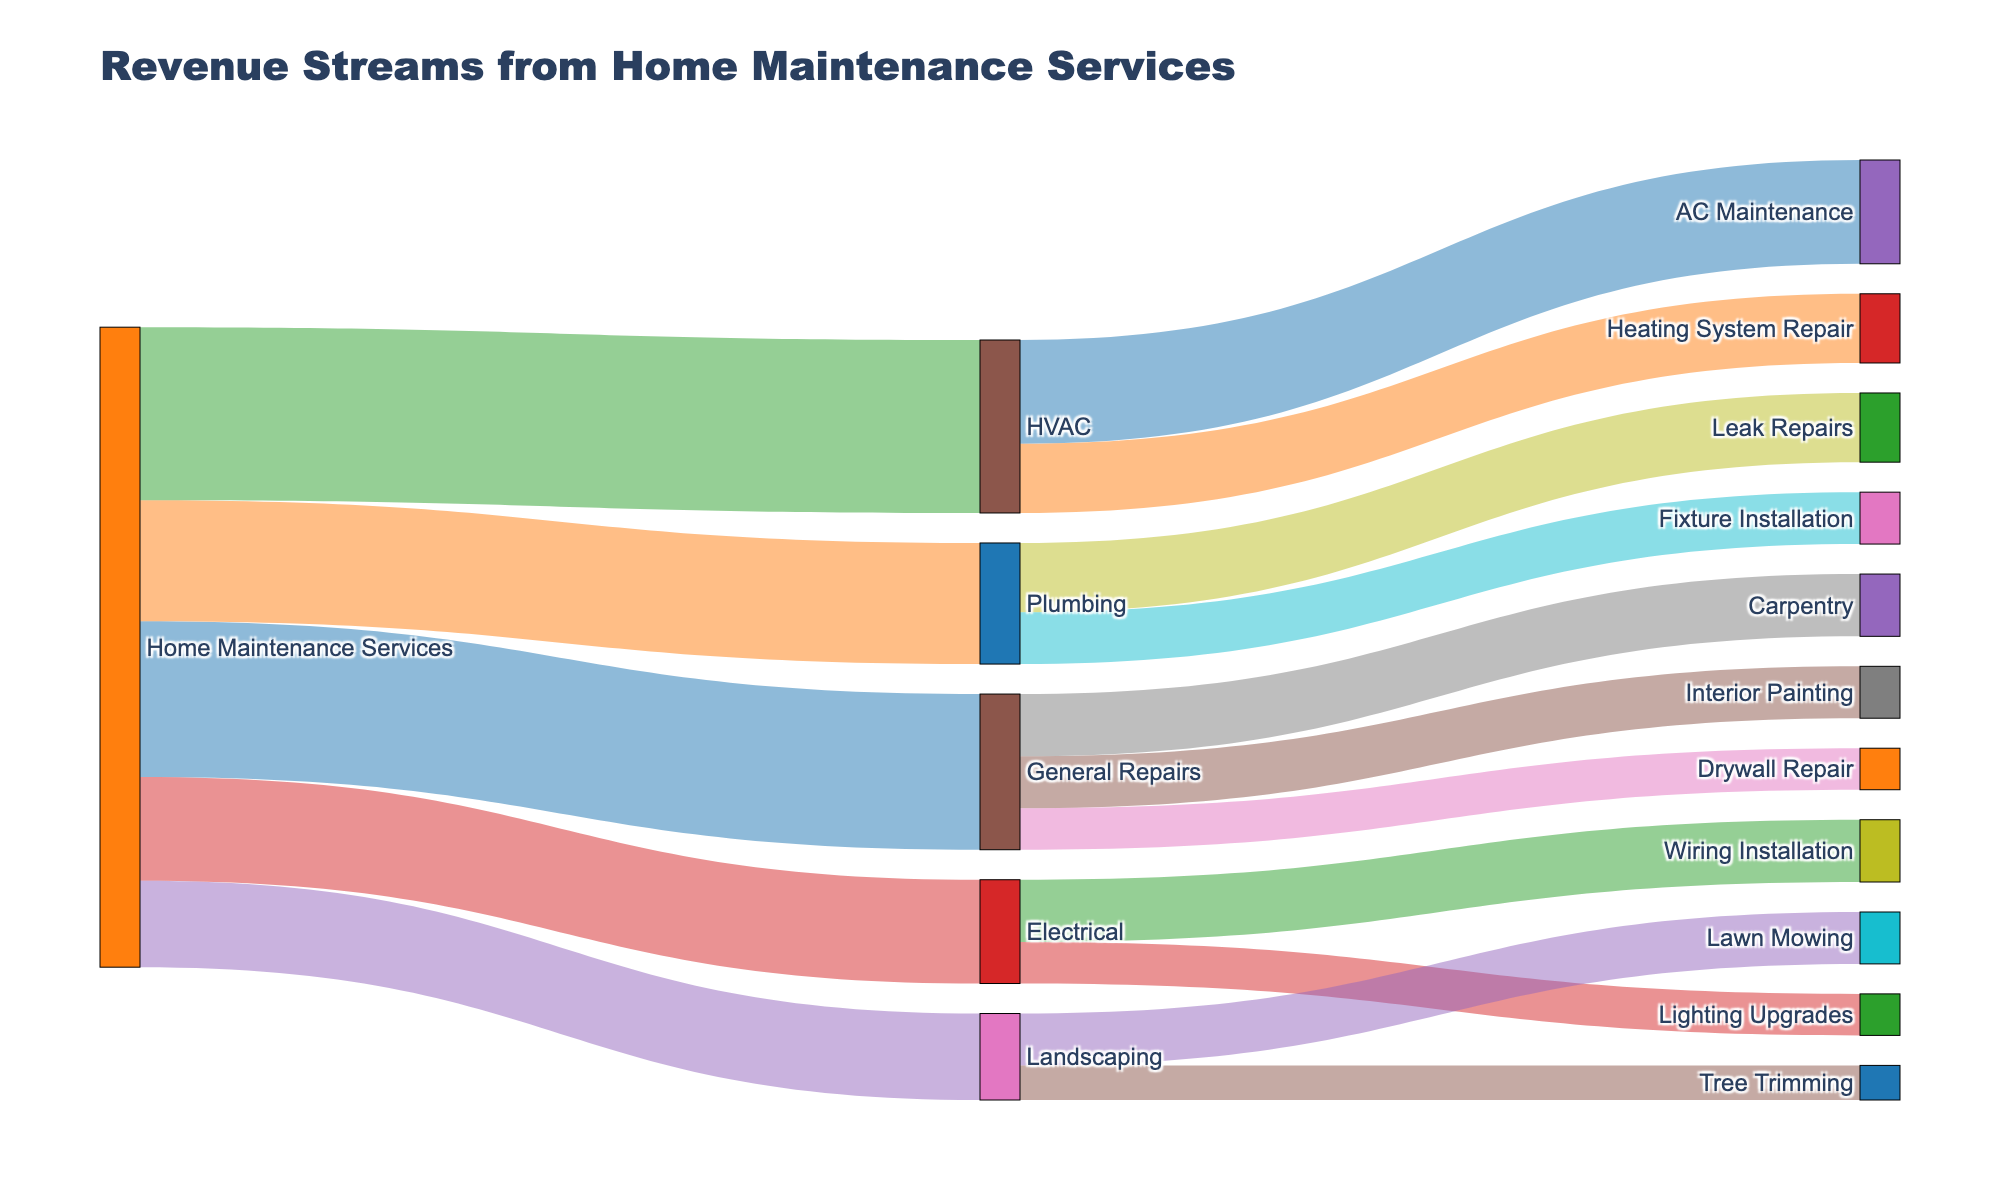how many main categories of home maintenance services are represented in the diagram? Look for nodes that originate from 'Home Maintenance Services'. These are the main categories. They include General Repairs, Plumbing, HVAC, Electrical, and Landscaping, totaling 5 categories.
Answer: 5 Which home maintenance service generates the highest revenue? Compare the values associated with each service originating from 'Home Maintenance Services'. The highest value is HVAC with $50,000.
Answer: HVAC What is the total revenue generated from general repairs services? Sum the values of the services under General Repairs: Interior Painting ($15,000) + Drywall Repair ($12,000) + Carpentry ($18,000).
Answer: $45,000 How does the revenue from electrical services compare to plumbing services? Check the revenue values originating from 'Home Maintenance Services' to 'Electrical' and 'Plumbing': Electrical ($30,000) vs. Plumbing ($35,000).
Answer: Plumbing generates more revenue than Electrical What percentage of total revenue comes from HVAC services? Calculate the total revenue from all services and the revenue from HVAC. Percentage = (HVAC revenue / Total revenue) x 100 = ($50,000 / $185,000) x 100
Answer: 27.03% Which sub-service under HVAC has higher revenue, AC Maintenance or Heating System Repair? Compare the values for AC Maintenance ($30,000) and Heating System Repair ($20,000).
Answer: AC Maintenance What is the combined revenue from all sub-services under plumbing? Sum the values of sub-services under Plumbing: Leak Repairs ($20,000) + Fixture Installation ($15,000).
Answer: $35,000 Is the revenue from landscaping services higher or lower than the revenue from electrical services? Compare the total revenue for Landscaping ($25,000) and Electrical ($30,000).
Answer: Lower What is the most significant revenue stream under General Repairs? Compare the values for sub-services under General Repairs: Interior Painting ($15,000), Drywall Repair ($12,000), Carpentry ($18,000).
Answer: Carpentry How many different revenue streams are depicted in the diagram? Count all unique entries in the 'target' column: General Repairs, Plumbing, HVAC, Electrical, Landscaping, Interior Painting, Drywall Repair, Carpentry, Leak Repairs, Fixture Installation, AC Maintenance, Heating System Repair, Wiring Installation, Lighting Upgrades, Lawn Mowing, Tree Trimming, totaling 16.
Answer: 16 